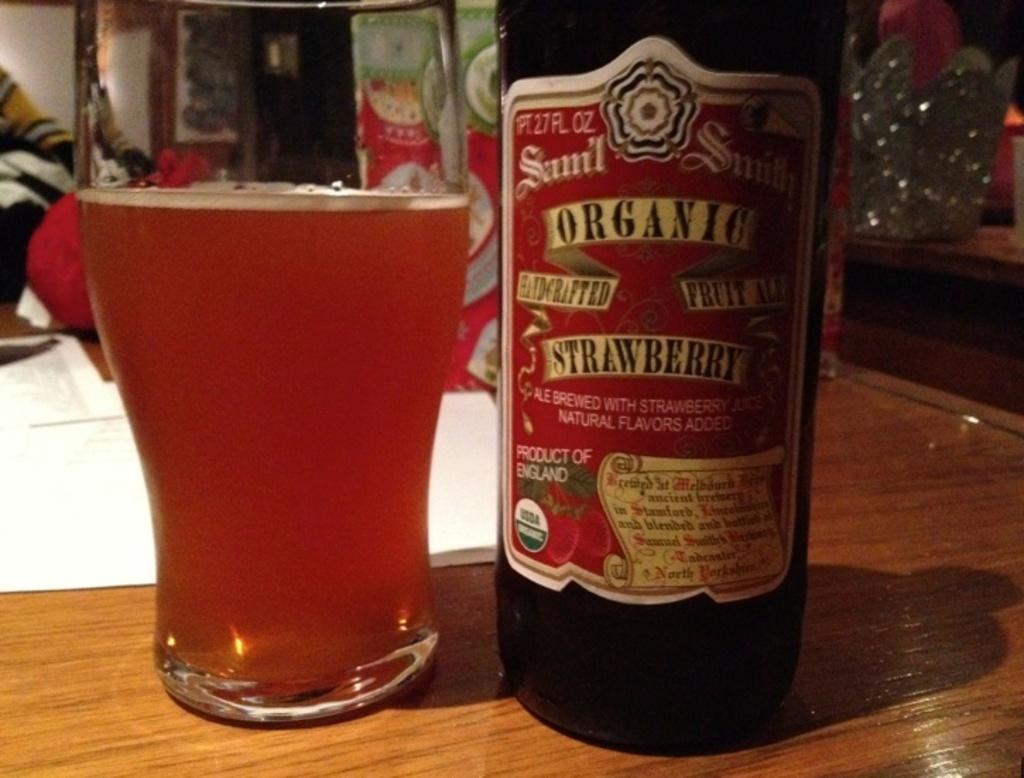What is the brand of beer?
Make the answer very short. Sam'l smith. 